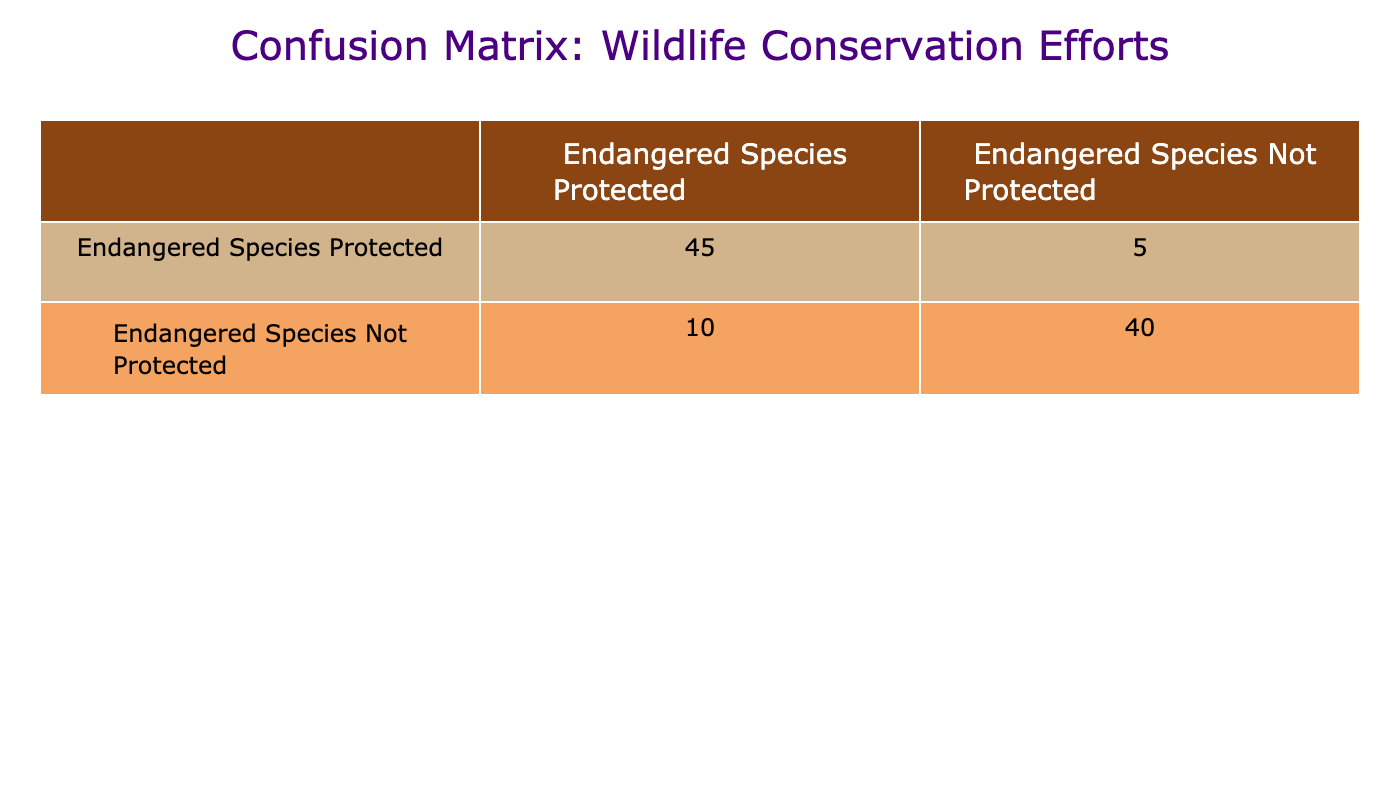What is the total number of endangered species that were successfully protected? In the table, the cell corresponding to "Endangered Species Protected" under "Endangered Species Protected" has the value 45. This figure represents the successful protection of endangered species.
Answer: 45 How many endangered species were actually not protected but predicted to be protected? From the table, the cell that corresponds to "Endangered Species Not Protected" under "Endangered Species Protected" has the value 10. This indicates the number of endangered species that were not protected despite being predicted to be protected.
Answer: 10 What is the total number of endangered species in the dataset? To find the total number of endangered species in the dataset, sum all the values in the table: 45 + 5 + 10 + 40 = 100. Thus, the total number is 100.
Answer: 100 Is there a higher number of endangered species that were correctly protected than those that were misidentified as protected? The number of endangered species correctly protected is 45, while those misidentified as protected is 10. Since 45 is greater than 10, the statement is true.
Answer: Yes What is the accuracy of the wildlife conservation efforts in protecting endangered species? Accuracy is calculated as the total number of correct predictions divided by the total number of predictions. The correct predictions are 45 (protected) + 40 (not protected) = 85. Total predictions are 100. Therefore, accuracy is 85/100 = 0.85 or 85%.
Answer: 85% What percentage of the endangered species were not protected despite the prediction that they would be protected? The number of endangered species not protected but predicted as protected is 10. The total number of endangered species is 100. The percentage is calculated as (10/100) * 100 = 10%.
Answer: 10% How many endangered species were incorrectly reported as not needing protection? The number of endangered species incorrectly reported as not needing protection is found in the cell corresponding to "Endangered Species Not Protected" under "Endangered Species Protected," which has a value of 5.
Answer: 5 Was the number of endangered species actually protected equal to those forecasted as needing protection? The number of endangered species protected is 45, and those forecasted as needing protection is 50 (45 protected plus 5 not protected). Since 45 does not equal 50, the answer is no.
Answer: No What is the difference between the number of endangered species protected and the number of endangered species predicted to be not protected? The number of endangered species protected is 45, and the number of endangered species predicted to be not protected is 5. The difference is calculated as 45 - 5 = 40.
Answer: 40 